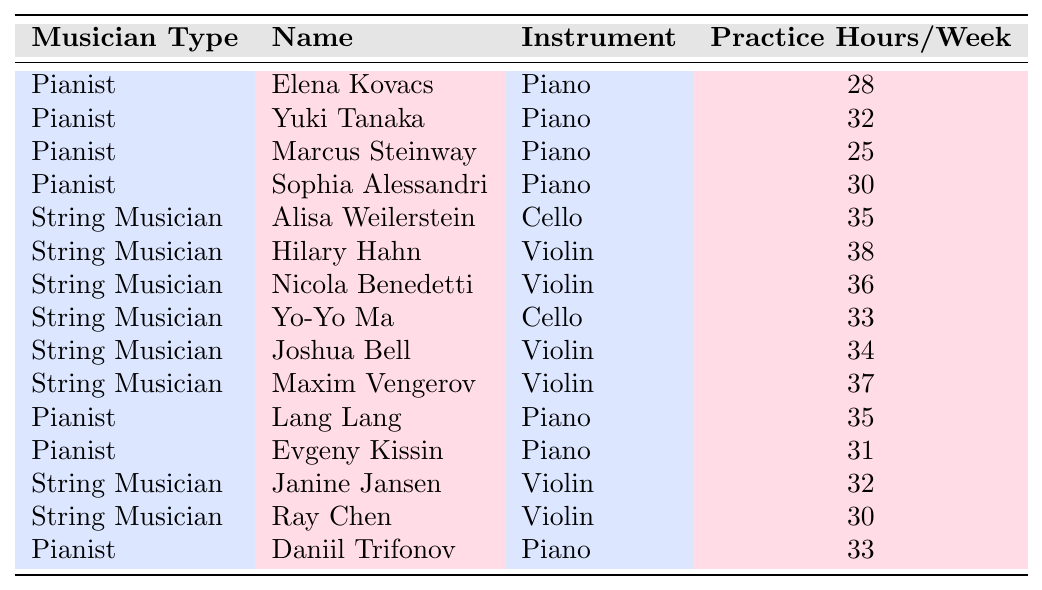What is the name of the pianist who practices the least? In the table, Marcus Steinway has the lowest practice hours per week at 25.
Answer: Marcus Steinway What is the average number of practice hours per week for string musicians? The string musicians' practice hours are 35, 38, 36, 33, 34, 37, 32, and 30. There are 8 string musicians, so the total is 35 + 38 + 36 + 33 + 34 + 37 + 32 + 30 = 305. Dividing by 8 gives an average of 305 / 8 = 38.125.
Answer: 38.125 Do more string musicians practice over 35 hours a week than pianists? For string musicians, Alisa Weilerstein, Hilary Hahn, Nicola Benedetti, Yo-Yo Ma, Joshua Bell, Maxim Vengerov practice over 35 hours (6 total). For pianists, only Lang Lang practices 35 hours (1 total). Thus, more string musicians practice over 35 hours.
Answer: Yes What is the total number of practice hours for all pianists? The practice hours for pianists are 28, 32, 25, 30, 35, 31, 33. Summing these gives 28 + 32 + 25 + 30 + 35 + 31 + 33 =  214.
Answer: 214 Who has the highest number of practice hours per week overall? Looking through both groups, Hilary Hahn has the highest at 38 hours per week, which is confirmed by comparing the practice hours across all musicians.
Answer: Hilary Hahn What percentage of string musicians practice more than 35 hours a week? Out of 8 string musicians, 4 practice more than 35 hours (Alisa Weilerstein, Hilary Hahn, Nicola Benedetti, Maxim Vengerov). Thus, 4 out of 8 is 50%.
Answer: 50% How many more hours does the average string musician practice compared to the average pianist? The average practice hours for string musicians is 38.125, and for pianists, it is calculated as follows: (28 + 32 + 25 + 30 + 35 + 31 + 33) / 7 = 30.7142857. The difference is 38.125 - 30.7142857 = 7.4107143, approximately 7.41 hours.
Answer: Approximately 7.41 hours Which violinist practices exactly 32 hours? The table lists Janine Jansen as the violinist who practices exactly 32 hours a week.
Answer: Janine Jansen Is there any pianist who practices 31 hours? Checking the table, Evgeny Kissin practices exactly 31 hours a week.
Answer: Yes What is the range of practice hours for pianists? The lowest practice hour is 25 (Marcus Steinway) and the highest is 35 (Lang Lang). Thus, the range is calculated as 35 - 25 = 10 hours.
Answer: 10 hours How many string musicians practice less than 34 hours a week? In the table, the following string musicians practice less than 34 hours: Yo-Yo Ma (33), Joshua Bell (34), Janine Jansen (32), Ray Chen (30). That totals 4 string musicians.
Answer: 4 